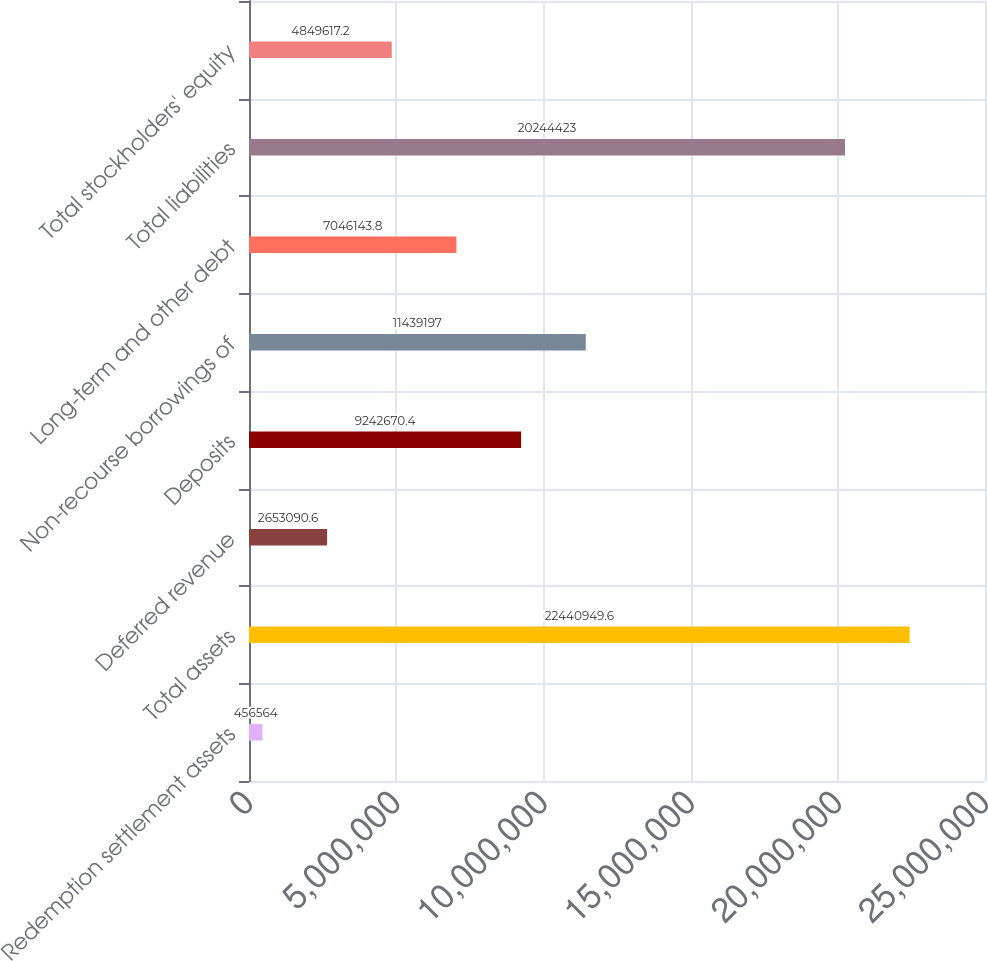Convert chart. <chart><loc_0><loc_0><loc_500><loc_500><bar_chart><fcel>Redemption settlement assets<fcel>Total assets<fcel>Deferred revenue<fcel>Deposits<fcel>Non-recourse borrowings of<fcel>Long-term and other debt<fcel>Total liabilities<fcel>Total stockholders' equity<nl><fcel>456564<fcel>2.24409e+07<fcel>2.65309e+06<fcel>9.24267e+06<fcel>1.14392e+07<fcel>7.04614e+06<fcel>2.02444e+07<fcel>4.84962e+06<nl></chart> 